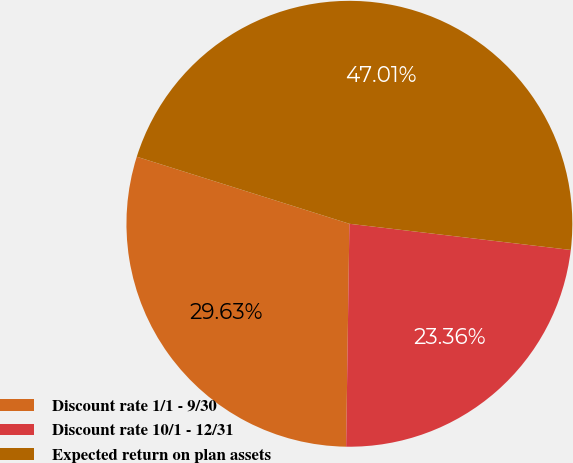<chart> <loc_0><loc_0><loc_500><loc_500><pie_chart><fcel>Discount rate 1/1 - 9/30<fcel>Discount rate 10/1 - 12/31<fcel>Expected return on plan assets<nl><fcel>29.63%<fcel>23.36%<fcel>47.01%<nl></chart> 